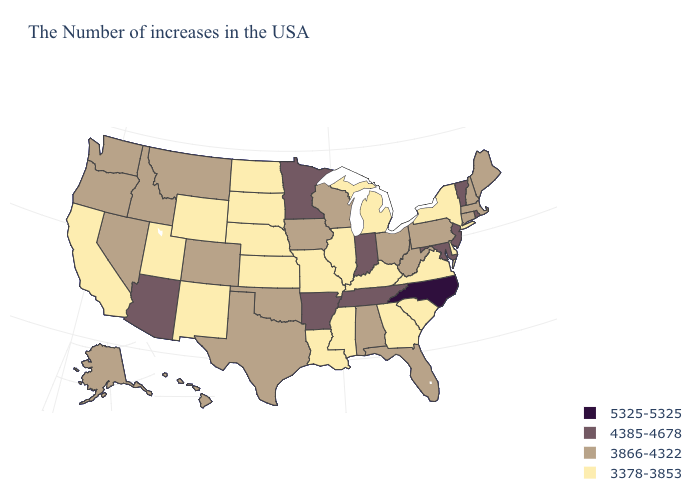What is the highest value in states that border Wyoming?
Short answer required. 3866-4322. How many symbols are there in the legend?
Answer briefly. 4. Does the map have missing data?
Write a very short answer. No. Which states have the lowest value in the Northeast?
Keep it brief. New York. Name the states that have a value in the range 3378-3853?
Short answer required. New York, Delaware, Virginia, South Carolina, Georgia, Michigan, Kentucky, Illinois, Mississippi, Louisiana, Missouri, Kansas, Nebraska, South Dakota, North Dakota, Wyoming, New Mexico, Utah, California. Among the states that border Maryland , does Virginia have the lowest value?
Concise answer only. Yes. Does Hawaii have a lower value than New Jersey?
Concise answer only. Yes. Which states have the lowest value in the West?
Short answer required. Wyoming, New Mexico, Utah, California. What is the lowest value in the West?
Short answer required. 3378-3853. Among the states that border Wyoming , which have the highest value?
Write a very short answer. Colorado, Montana, Idaho. Name the states that have a value in the range 5325-5325?
Give a very brief answer. North Carolina. What is the lowest value in the USA?
Write a very short answer. 3378-3853. Name the states that have a value in the range 3866-4322?
Be succinct. Maine, Massachusetts, New Hampshire, Connecticut, Pennsylvania, West Virginia, Ohio, Florida, Alabama, Wisconsin, Iowa, Oklahoma, Texas, Colorado, Montana, Idaho, Nevada, Washington, Oregon, Alaska, Hawaii. Among the states that border North Dakota , which have the lowest value?
Keep it brief. South Dakota. Among the states that border Missouri , does Tennessee have the highest value?
Keep it brief. Yes. 